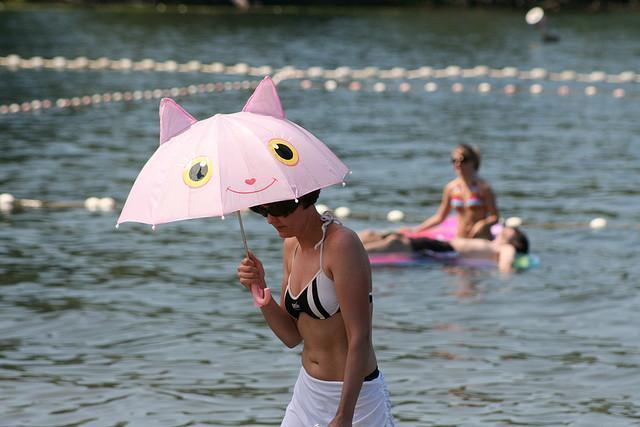How many people are in the photo?
Give a very brief answer. 3. 